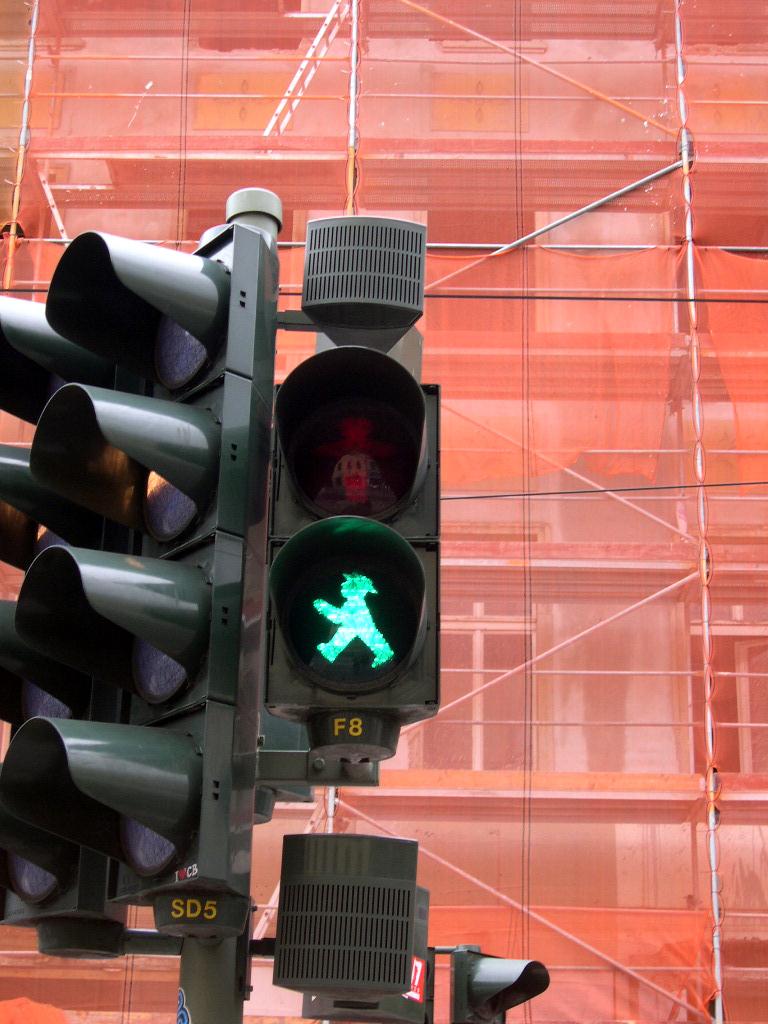What letter and number is under the green light?
Your answer should be compact. F8. What letters are at the very bottom of the screen?
Your answer should be very brief. Sd. 